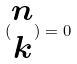Convert formula to latex. <formula><loc_0><loc_0><loc_500><loc_500>( \begin{matrix} n \\ k \end{matrix} ) = 0</formula> 